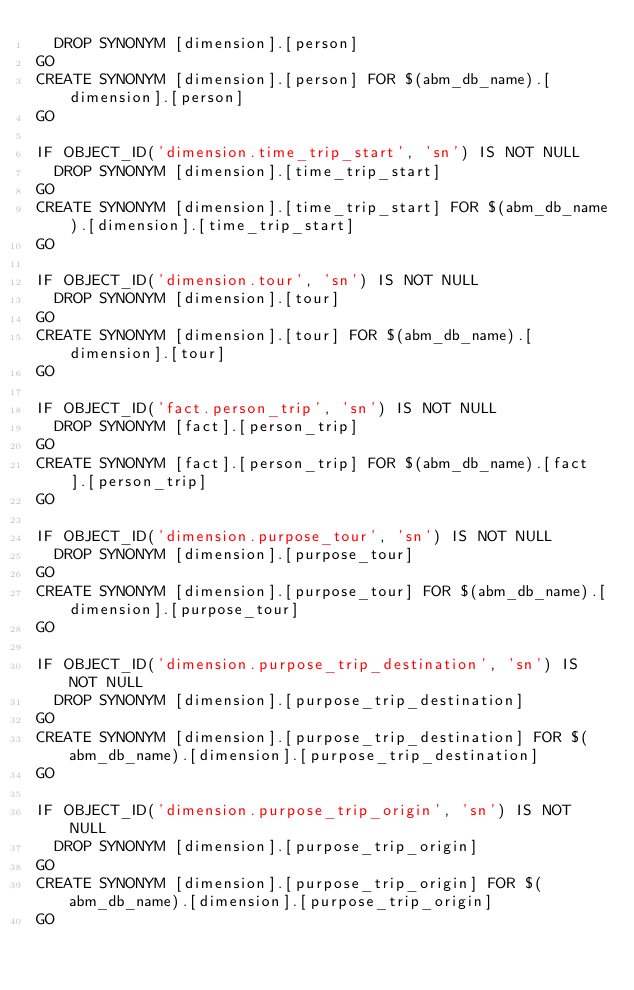Convert code to text. <code><loc_0><loc_0><loc_500><loc_500><_SQL_>	DROP SYNONYM [dimension].[person]
GO
CREATE SYNONYM [dimension].[person] FOR $(abm_db_name).[dimension].[person]
GO

IF OBJECT_ID('dimension.time_trip_start', 'sn') IS NOT NULL
	DROP SYNONYM [dimension].[time_trip_start]
GO
CREATE SYNONYM [dimension].[time_trip_start] FOR $(abm_db_name).[dimension].[time_trip_start]
GO

IF OBJECT_ID('dimension.tour', 'sn') IS NOT NULL
	DROP SYNONYM [dimension].[tour]
GO
CREATE SYNONYM [dimension].[tour] FOR $(abm_db_name).[dimension].[tour]
GO

IF OBJECT_ID('fact.person_trip', 'sn') IS NOT NULL
	DROP SYNONYM [fact].[person_trip]
GO
CREATE SYNONYM [fact].[person_trip] FOR $(abm_db_name).[fact].[person_trip]
GO

IF OBJECT_ID('dimension.purpose_tour', 'sn') IS NOT NULL
	DROP SYNONYM [dimension].[purpose_tour]
GO
CREATE SYNONYM [dimension].[purpose_tour] FOR $(abm_db_name).[dimension].[purpose_tour]
GO

IF OBJECT_ID('dimension.purpose_trip_destination', 'sn') IS NOT NULL
	DROP SYNONYM [dimension].[purpose_trip_destination]
GO
CREATE SYNONYM [dimension].[purpose_trip_destination] FOR $(abm_db_name).[dimension].[purpose_trip_destination]
GO

IF OBJECT_ID('dimension.purpose_trip_origin', 'sn') IS NOT NULL
	DROP SYNONYM [dimension].[purpose_trip_origin]
GO
CREATE SYNONYM [dimension].[purpose_trip_origin] FOR $(abm_db_name).[dimension].[purpose_trip_origin]
GO
</code> 